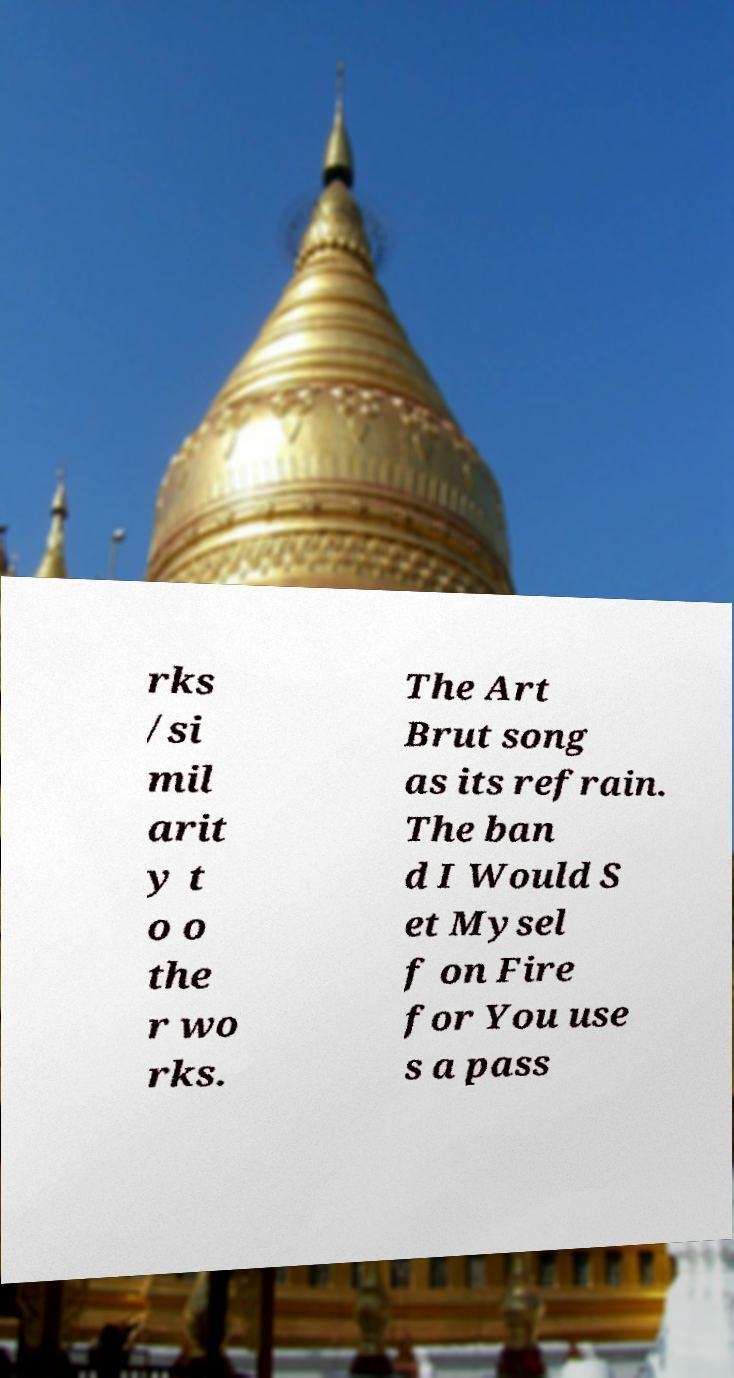Please identify and transcribe the text found in this image. rks /si mil arit y t o o the r wo rks. The Art Brut song as its refrain. The ban d I Would S et Mysel f on Fire for You use s a pass 